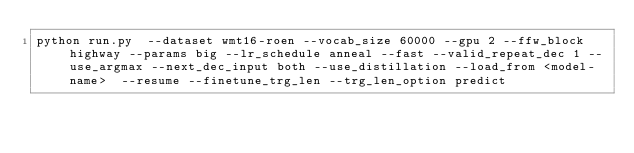<code> <loc_0><loc_0><loc_500><loc_500><_Bash_>python run.py  --dataset wmt16-roen --vocab_size 60000 --gpu 2 --ffw_block highway --params big --lr_schedule anneal --fast --valid_repeat_dec 1 --use_argmax --next_dec_input both --use_distillation --load_from <model-name>  --resume --finetune_trg_len --trg_len_option predict


</code> 